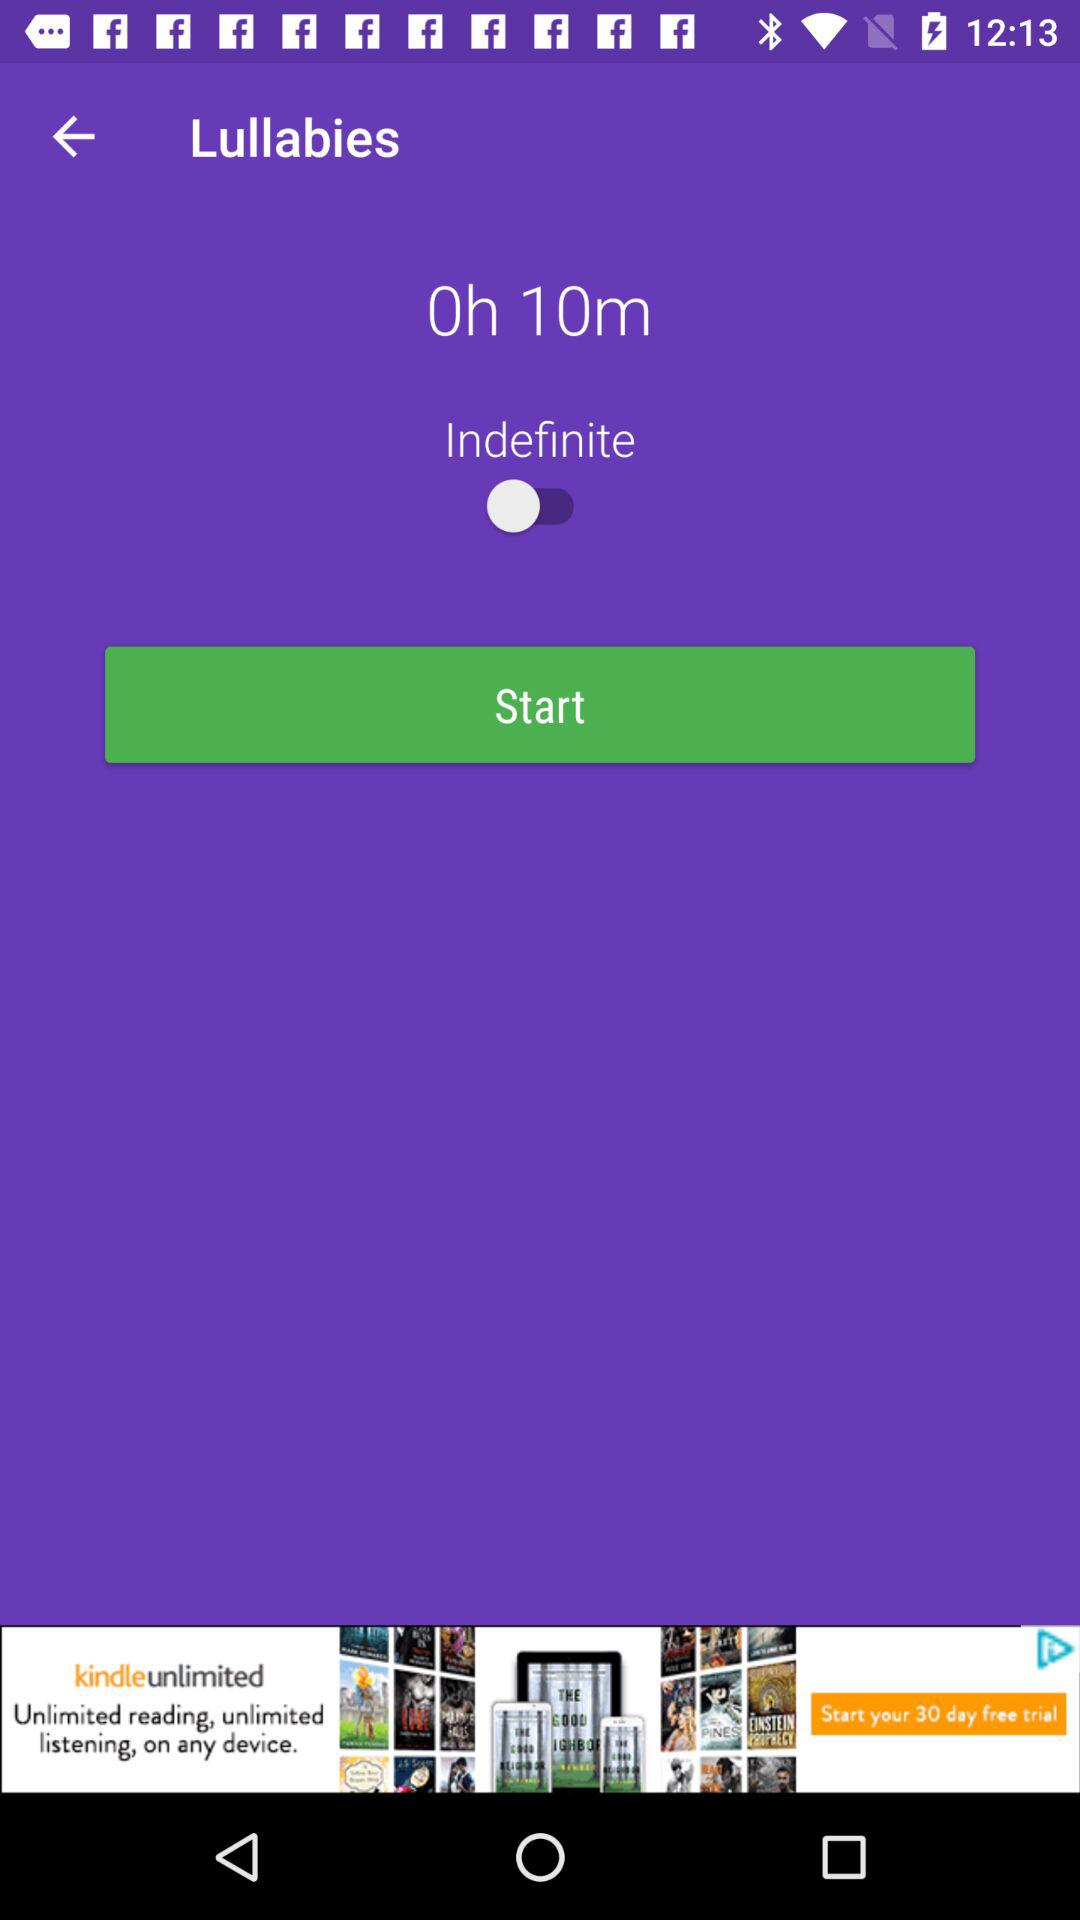Which section of the application is shown? The shown section is "Lullabies". 